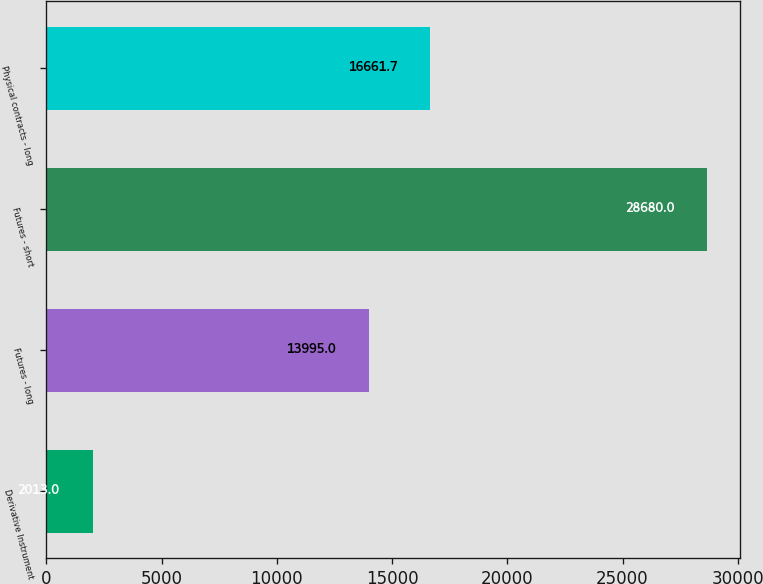<chart> <loc_0><loc_0><loc_500><loc_500><bar_chart><fcel>Derivative Instrument<fcel>Futures - long<fcel>Futures - short<fcel>Physical contracts - long<nl><fcel>2013<fcel>13995<fcel>28680<fcel>16661.7<nl></chart> 